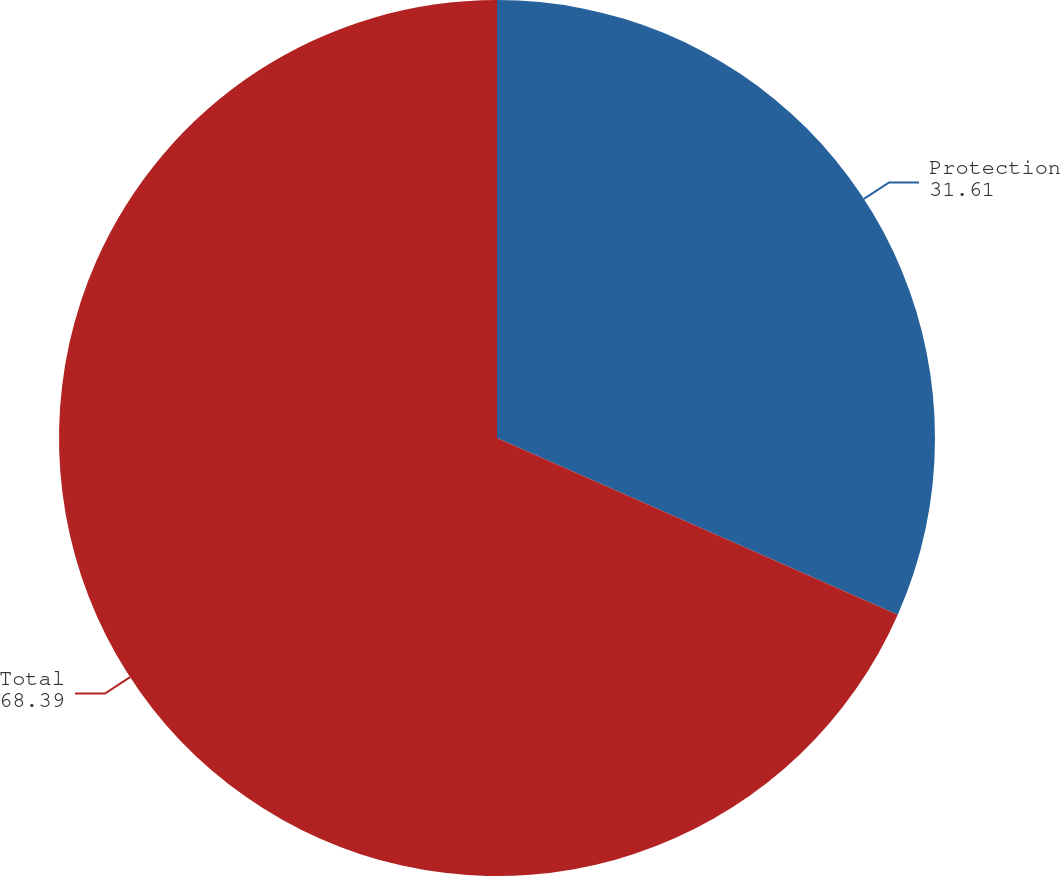<chart> <loc_0><loc_0><loc_500><loc_500><pie_chart><fcel>Protection<fcel>Total<nl><fcel>31.61%<fcel>68.39%<nl></chart> 